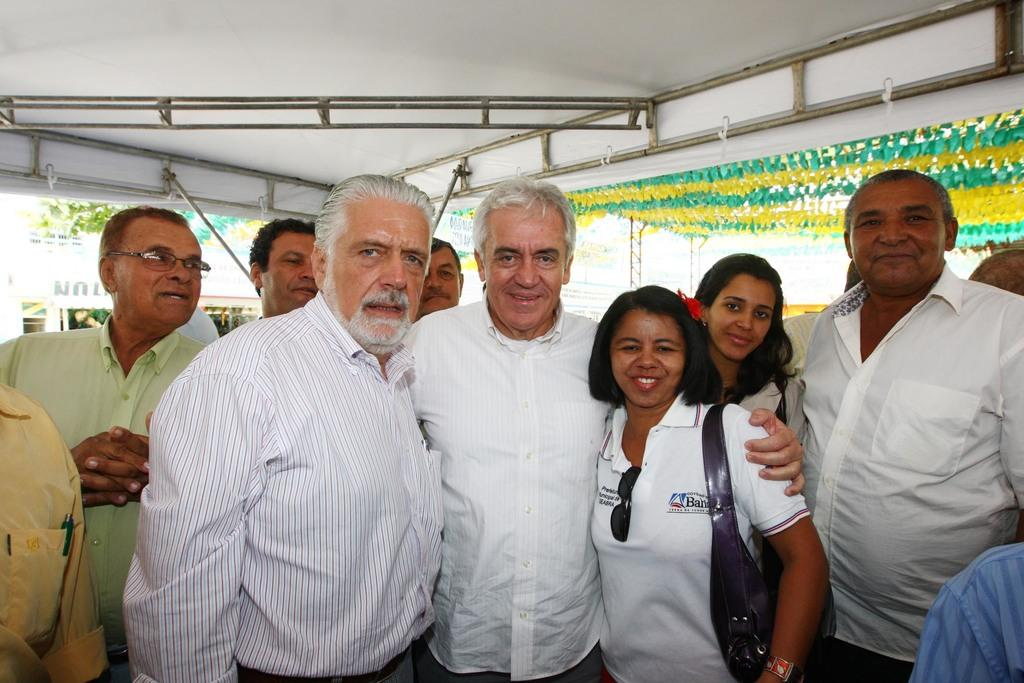What can be seen in the image? There are people standing in the image. Where are the people standing? The people are standing on the floor. What is visible in the background of the image? There are buildings and trees in the background of the image. What grade does the bedroom receive in the image? There is no bedroom present in the image, so it is not possible to assign a grade. 